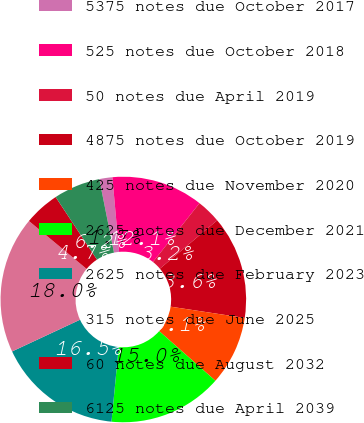Convert chart to OTSL. <chart><loc_0><loc_0><loc_500><loc_500><pie_chart><fcel>5375 notes due October 2017<fcel>525 notes due October 2018<fcel>50 notes due April 2019<fcel>4875 notes due October 2019<fcel>425 notes due November 2020<fcel>2625 notes due December 2021<fcel>2625 notes due February 2023<fcel>315 notes due June 2025<fcel>60 notes due August 2032<fcel>6125 notes due April 2039<nl><fcel>1.72%<fcel>12.07%<fcel>3.2%<fcel>13.55%<fcel>9.11%<fcel>15.03%<fcel>16.51%<fcel>17.99%<fcel>4.67%<fcel>6.15%<nl></chart> 